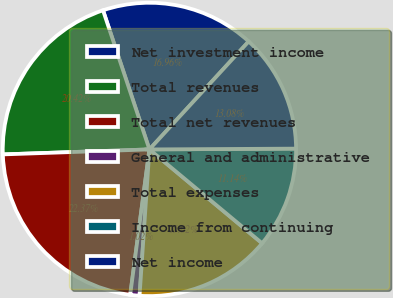<chart> <loc_0><loc_0><loc_500><loc_500><pie_chart><fcel>Net investment income<fcel>Total revenues<fcel>Total net revenues<fcel>General and administrative<fcel>Total expenses<fcel>Income from continuing<fcel>Net income<nl><fcel>16.96%<fcel>20.42%<fcel>22.37%<fcel>1.02%<fcel>15.02%<fcel>11.14%<fcel>13.08%<nl></chart> 